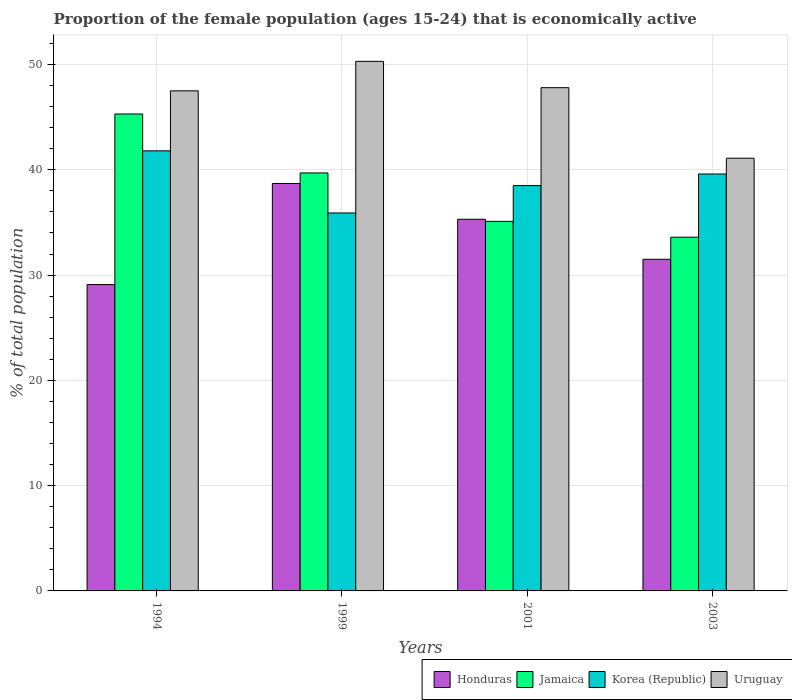How many groups of bars are there?
Keep it short and to the point. 4. Are the number of bars on each tick of the X-axis equal?
Make the answer very short. Yes. How many bars are there on the 4th tick from the right?
Your response must be concise. 4. What is the proportion of the female population that is economically active in Korea (Republic) in 2003?
Your answer should be compact. 39.6. Across all years, what is the maximum proportion of the female population that is economically active in Jamaica?
Offer a terse response. 45.3. Across all years, what is the minimum proportion of the female population that is economically active in Jamaica?
Offer a very short reply. 33.6. What is the total proportion of the female population that is economically active in Korea (Republic) in the graph?
Offer a very short reply. 155.8. What is the difference between the proportion of the female population that is economically active in Jamaica in 1994 and that in 2003?
Your answer should be compact. 11.7. What is the average proportion of the female population that is economically active in Uruguay per year?
Provide a succinct answer. 46.67. In the year 2003, what is the difference between the proportion of the female population that is economically active in Jamaica and proportion of the female population that is economically active in Uruguay?
Provide a short and direct response. -7.5. What is the ratio of the proportion of the female population that is economically active in Uruguay in 2001 to that in 2003?
Make the answer very short. 1.16. Is the proportion of the female population that is economically active in Honduras in 1999 less than that in 2001?
Your answer should be very brief. No. Is the difference between the proportion of the female population that is economically active in Jamaica in 2001 and 2003 greater than the difference between the proportion of the female population that is economically active in Uruguay in 2001 and 2003?
Provide a short and direct response. No. What is the difference between the highest and the second highest proportion of the female population that is economically active in Korea (Republic)?
Your answer should be very brief. 2.2. What is the difference between the highest and the lowest proportion of the female population that is economically active in Uruguay?
Your answer should be very brief. 9.2. In how many years, is the proportion of the female population that is economically active in Jamaica greater than the average proportion of the female population that is economically active in Jamaica taken over all years?
Make the answer very short. 2. Is the sum of the proportion of the female population that is economically active in Korea (Republic) in 1994 and 1999 greater than the maximum proportion of the female population that is economically active in Jamaica across all years?
Provide a succinct answer. Yes. Is it the case that in every year, the sum of the proportion of the female population that is economically active in Jamaica and proportion of the female population that is economically active in Korea (Republic) is greater than the sum of proportion of the female population that is economically active in Uruguay and proportion of the female population that is economically active in Honduras?
Ensure brevity in your answer.  No. What does the 2nd bar from the left in 1999 represents?
Your answer should be compact. Jamaica. What does the 4th bar from the right in 2001 represents?
Provide a short and direct response. Honduras. What is the difference between two consecutive major ticks on the Y-axis?
Your response must be concise. 10. Are the values on the major ticks of Y-axis written in scientific E-notation?
Your response must be concise. No. Does the graph contain any zero values?
Your answer should be compact. No. Where does the legend appear in the graph?
Your answer should be compact. Bottom right. How are the legend labels stacked?
Your response must be concise. Horizontal. What is the title of the graph?
Offer a terse response. Proportion of the female population (ages 15-24) that is economically active. What is the label or title of the X-axis?
Offer a very short reply. Years. What is the label or title of the Y-axis?
Offer a terse response. % of total population. What is the % of total population of Honduras in 1994?
Keep it short and to the point. 29.1. What is the % of total population of Jamaica in 1994?
Give a very brief answer. 45.3. What is the % of total population in Korea (Republic) in 1994?
Offer a terse response. 41.8. What is the % of total population of Uruguay in 1994?
Offer a terse response. 47.5. What is the % of total population of Honduras in 1999?
Provide a short and direct response. 38.7. What is the % of total population in Jamaica in 1999?
Offer a very short reply. 39.7. What is the % of total population in Korea (Republic) in 1999?
Your answer should be compact. 35.9. What is the % of total population of Uruguay in 1999?
Offer a very short reply. 50.3. What is the % of total population in Honduras in 2001?
Offer a terse response. 35.3. What is the % of total population of Jamaica in 2001?
Make the answer very short. 35.1. What is the % of total population of Korea (Republic) in 2001?
Your answer should be compact. 38.5. What is the % of total population in Uruguay in 2001?
Offer a terse response. 47.8. What is the % of total population in Honduras in 2003?
Make the answer very short. 31.5. What is the % of total population of Jamaica in 2003?
Give a very brief answer. 33.6. What is the % of total population of Korea (Republic) in 2003?
Provide a short and direct response. 39.6. What is the % of total population in Uruguay in 2003?
Your response must be concise. 41.1. Across all years, what is the maximum % of total population of Honduras?
Offer a very short reply. 38.7. Across all years, what is the maximum % of total population in Jamaica?
Provide a short and direct response. 45.3. Across all years, what is the maximum % of total population of Korea (Republic)?
Your answer should be compact. 41.8. Across all years, what is the maximum % of total population of Uruguay?
Make the answer very short. 50.3. Across all years, what is the minimum % of total population of Honduras?
Your response must be concise. 29.1. Across all years, what is the minimum % of total population of Jamaica?
Keep it short and to the point. 33.6. Across all years, what is the minimum % of total population in Korea (Republic)?
Your answer should be compact. 35.9. Across all years, what is the minimum % of total population in Uruguay?
Make the answer very short. 41.1. What is the total % of total population in Honduras in the graph?
Your response must be concise. 134.6. What is the total % of total population in Jamaica in the graph?
Ensure brevity in your answer.  153.7. What is the total % of total population in Korea (Republic) in the graph?
Give a very brief answer. 155.8. What is the total % of total population of Uruguay in the graph?
Ensure brevity in your answer.  186.7. What is the difference between the % of total population in Honduras in 1994 and that in 1999?
Provide a succinct answer. -9.6. What is the difference between the % of total population in Jamaica in 1994 and that in 1999?
Keep it short and to the point. 5.6. What is the difference between the % of total population of Uruguay in 1994 and that in 1999?
Give a very brief answer. -2.8. What is the difference between the % of total population in Korea (Republic) in 1994 and that in 2001?
Make the answer very short. 3.3. What is the difference between the % of total population in Korea (Republic) in 1994 and that in 2003?
Ensure brevity in your answer.  2.2. What is the difference between the % of total population in Honduras in 1999 and that in 2001?
Make the answer very short. 3.4. What is the difference between the % of total population of Jamaica in 1999 and that in 2001?
Provide a short and direct response. 4.6. What is the difference between the % of total population of Korea (Republic) in 1999 and that in 2001?
Your response must be concise. -2.6. What is the difference between the % of total population in Jamaica in 1999 and that in 2003?
Ensure brevity in your answer.  6.1. What is the difference between the % of total population in Korea (Republic) in 1999 and that in 2003?
Your answer should be compact. -3.7. What is the difference between the % of total population in Uruguay in 1999 and that in 2003?
Provide a short and direct response. 9.2. What is the difference between the % of total population of Honduras in 2001 and that in 2003?
Ensure brevity in your answer.  3.8. What is the difference between the % of total population of Honduras in 1994 and the % of total population of Jamaica in 1999?
Make the answer very short. -10.6. What is the difference between the % of total population in Honduras in 1994 and the % of total population in Korea (Republic) in 1999?
Your response must be concise. -6.8. What is the difference between the % of total population in Honduras in 1994 and the % of total population in Uruguay in 1999?
Your answer should be compact. -21.2. What is the difference between the % of total population of Jamaica in 1994 and the % of total population of Korea (Republic) in 1999?
Provide a succinct answer. 9.4. What is the difference between the % of total population in Honduras in 1994 and the % of total population in Korea (Republic) in 2001?
Keep it short and to the point. -9.4. What is the difference between the % of total population in Honduras in 1994 and the % of total population in Uruguay in 2001?
Your response must be concise. -18.7. What is the difference between the % of total population of Jamaica in 1994 and the % of total population of Korea (Republic) in 2001?
Your answer should be very brief. 6.8. What is the difference between the % of total population of Honduras in 1994 and the % of total population of Jamaica in 2003?
Your response must be concise. -4.5. What is the difference between the % of total population of Honduras in 1994 and the % of total population of Korea (Republic) in 2003?
Make the answer very short. -10.5. What is the difference between the % of total population of Honduras in 1994 and the % of total population of Uruguay in 2003?
Ensure brevity in your answer.  -12. What is the difference between the % of total population of Jamaica in 1994 and the % of total population of Korea (Republic) in 2003?
Your answer should be very brief. 5.7. What is the difference between the % of total population in Jamaica in 1994 and the % of total population in Uruguay in 2003?
Your answer should be compact. 4.2. What is the difference between the % of total population in Honduras in 1999 and the % of total population in Korea (Republic) in 2001?
Provide a succinct answer. 0.2. What is the difference between the % of total population of Jamaica in 1999 and the % of total population of Korea (Republic) in 2001?
Provide a succinct answer. 1.2. What is the difference between the % of total population in Korea (Republic) in 1999 and the % of total population in Uruguay in 2001?
Your answer should be very brief. -11.9. What is the difference between the % of total population of Honduras in 1999 and the % of total population of Uruguay in 2003?
Offer a terse response. -2.4. What is the difference between the % of total population of Jamaica in 1999 and the % of total population of Uruguay in 2003?
Keep it short and to the point. -1.4. What is the difference between the % of total population of Korea (Republic) in 1999 and the % of total population of Uruguay in 2003?
Your answer should be very brief. -5.2. What is the difference between the % of total population in Honduras in 2001 and the % of total population in Jamaica in 2003?
Ensure brevity in your answer.  1.7. What is the difference between the % of total population of Honduras in 2001 and the % of total population of Korea (Republic) in 2003?
Your answer should be very brief. -4.3. What is the difference between the % of total population of Jamaica in 2001 and the % of total population of Korea (Republic) in 2003?
Offer a very short reply. -4.5. What is the average % of total population of Honduras per year?
Give a very brief answer. 33.65. What is the average % of total population in Jamaica per year?
Your answer should be very brief. 38.42. What is the average % of total population of Korea (Republic) per year?
Your answer should be very brief. 38.95. What is the average % of total population of Uruguay per year?
Your answer should be compact. 46.67. In the year 1994, what is the difference between the % of total population of Honduras and % of total population of Jamaica?
Ensure brevity in your answer.  -16.2. In the year 1994, what is the difference between the % of total population of Honduras and % of total population of Korea (Republic)?
Keep it short and to the point. -12.7. In the year 1994, what is the difference between the % of total population in Honduras and % of total population in Uruguay?
Offer a terse response. -18.4. In the year 1994, what is the difference between the % of total population in Korea (Republic) and % of total population in Uruguay?
Offer a terse response. -5.7. In the year 1999, what is the difference between the % of total population in Honduras and % of total population in Korea (Republic)?
Give a very brief answer. 2.8. In the year 1999, what is the difference between the % of total population in Jamaica and % of total population in Korea (Republic)?
Ensure brevity in your answer.  3.8. In the year 1999, what is the difference between the % of total population of Jamaica and % of total population of Uruguay?
Offer a very short reply. -10.6. In the year 1999, what is the difference between the % of total population in Korea (Republic) and % of total population in Uruguay?
Offer a very short reply. -14.4. In the year 2001, what is the difference between the % of total population of Honduras and % of total population of Jamaica?
Your answer should be compact. 0.2. In the year 2001, what is the difference between the % of total population in Jamaica and % of total population in Uruguay?
Provide a short and direct response. -12.7. In the year 2003, what is the difference between the % of total population of Honduras and % of total population of Korea (Republic)?
Provide a short and direct response. -8.1. In the year 2003, what is the difference between the % of total population of Jamaica and % of total population of Korea (Republic)?
Your response must be concise. -6. What is the ratio of the % of total population in Honduras in 1994 to that in 1999?
Your answer should be compact. 0.75. What is the ratio of the % of total population in Jamaica in 1994 to that in 1999?
Provide a short and direct response. 1.14. What is the ratio of the % of total population of Korea (Republic) in 1994 to that in 1999?
Make the answer very short. 1.16. What is the ratio of the % of total population in Uruguay in 1994 to that in 1999?
Provide a short and direct response. 0.94. What is the ratio of the % of total population in Honduras in 1994 to that in 2001?
Provide a short and direct response. 0.82. What is the ratio of the % of total population of Jamaica in 1994 to that in 2001?
Ensure brevity in your answer.  1.29. What is the ratio of the % of total population of Korea (Republic) in 1994 to that in 2001?
Keep it short and to the point. 1.09. What is the ratio of the % of total population in Honduras in 1994 to that in 2003?
Give a very brief answer. 0.92. What is the ratio of the % of total population in Jamaica in 1994 to that in 2003?
Your answer should be very brief. 1.35. What is the ratio of the % of total population of Korea (Republic) in 1994 to that in 2003?
Keep it short and to the point. 1.06. What is the ratio of the % of total population of Uruguay in 1994 to that in 2003?
Your answer should be compact. 1.16. What is the ratio of the % of total population of Honduras in 1999 to that in 2001?
Offer a very short reply. 1.1. What is the ratio of the % of total population in Jamaica in 1999 to that in 2001?
Keep it short and to the point. 1.13. What is the ratio of the % of total population in Korea (Republic) in 1999 to that in 2001?
Provide a succinct answer. 0.93. What is the ratio of the % of total population of Uruguay in 1999 to that in 2001?
Ensure brevity in your answer.  1.05. What is the ratio of the % of total population of Honduras in 1999 to that in 2003?
Offer a very short reply. 1.23. What is the ratio of the % of total population of Jamaica in 1999 to that in 2003?
Offer a very short reply. 1.18. What is the ratio of the % of total population in Korea (Republic) in 1999 to that in 2003?
Keep it short and to the point. 0.91. What is the ratio of the % of total population in Uruguay in 1999 to that in 2003?
Make the answer very short. 1.22. What is the ratio of the % of total population in Honduras in 2001 to that in 2003?
Ensure brevity in your answer.  1.12. What is the ratio of the % of total population of Jamaica in 2001 to that in 2003?
Keep it short and to the point. 1.04. What is the ratio of the % of total population in Korea (Republic) in 2001 to that in 2003?
Offer a very short reply. 0.97. What is the ratio of the % of total population in Uruguay in 2001 to that in 2003?
Your answer should be very brief. 1.16. What is the difference between the highest and the second highest % of total population in Jamaica?
Make the answer very short. 5.6. What is the difference between the highest and the second highest % of total population of Uruguay?
Your response must be concise. 2.5. What is the difference between the highest and the lowest % of total population in Korea (Republic)?
Provide a short and direct response. 5.9. What is the difference between the highest and the lowest % of total population of Uruguay?
Provide a succinct answer. 9.2. 